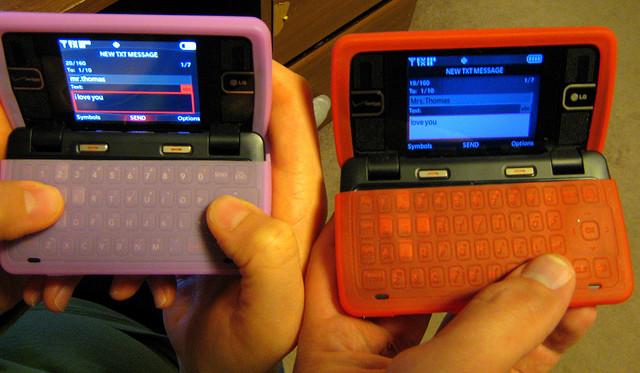Can you play this game?
Answer briefly. No. Are two people in the picture?
Keep it brief. Yes. What color is the phone on the right?
Quick response, please. Orange. 